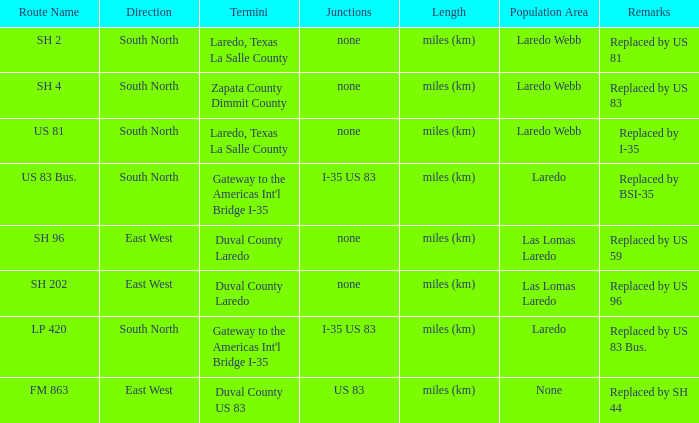Which courses have "replaced by us 81" stated in their remarks segment? SH 2. 